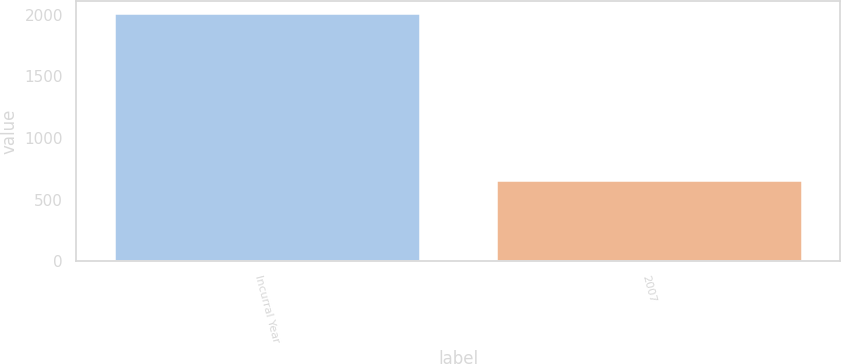<chart> <loc_0><loc_0><loc_500><loc_500><bar_chart><fcel>Incurral Year<fcel>2007<nl><fcel>2011<fcel>661<nl></chart> 